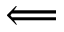Convert formula to latex. <formula><loc_0><loc_0><loc_500><loc_500>\Longleftarrow</formula> 